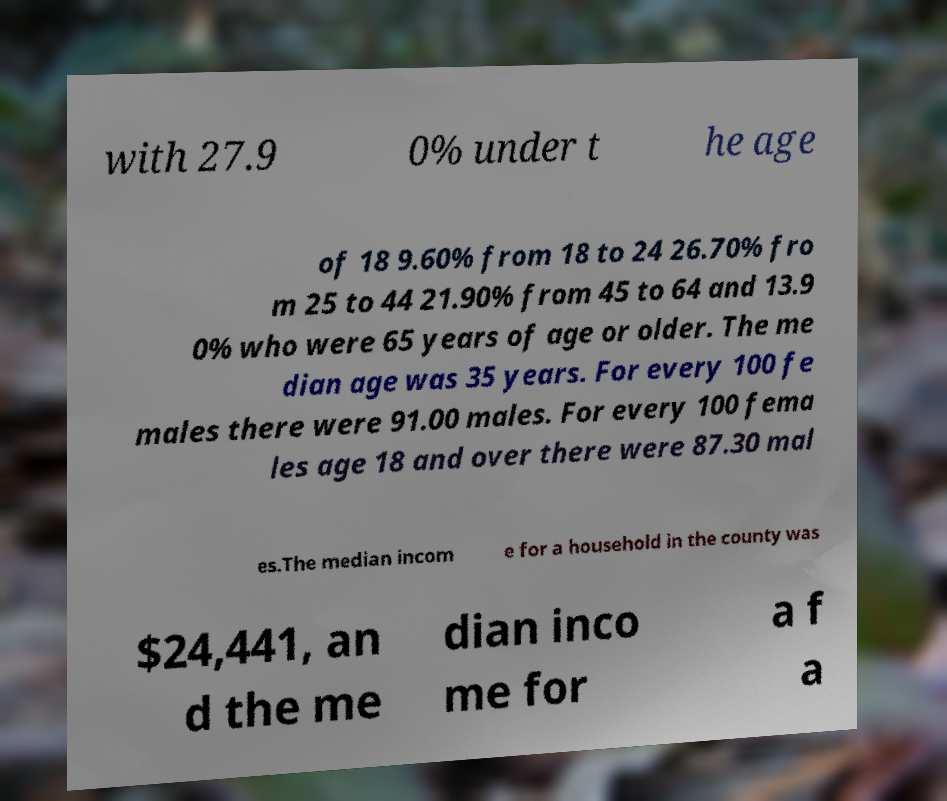Please read and relay the text visible in this image. What does it say? with 27.9 0% under t he age of 18 9.60% from 18 to 24 26.70% fro m 25 to 44 21.90% from 45 to 64 and 13.9 0% who were 65 years of age or older. The me dian age was 35 years. For every 100 fe males there were 91.00 males. For every 100 fema les age 18 and over there were 87.30 mal es.The median incom e for a household in the county was $24,441, an d the me dian inco me for a f a 